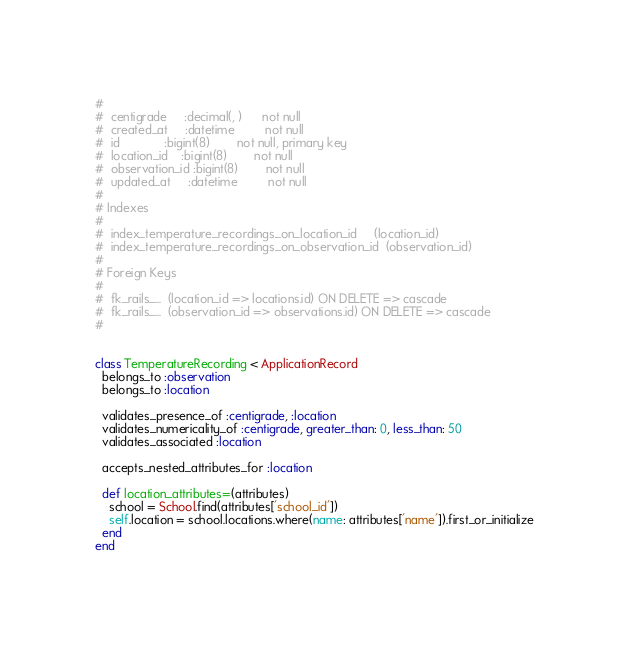<code> <loc_0><loc_0><loc_500><loc_500><_Ruby_>#
#  centigrade     :decimal(, )      not null
#  created_at     :datetime         not null
#  id             :bigint(8)        not null, primary key
#  location_id    :bigint(8)        not null
#  observation_id :bigint(8)        not null
#  updated_at     :datetime         not null
#
# Indexes
#
#  index_temperature_recordings_on_location_id     (location_id)
#  index_temperature_recordings_on_observation_id  (observation_id)
#
# Foreign Keys
#
#  fk_rails_...  (location_id => locations.id) ON DELETE => cascade
#  fk_rails_...  (observation_id => observations.id) ON DELETE => cascade
#


class TemperatureRecording < ApplicationRecord
  belongs_to :observation
  belongs_to :location

  validates_presence_of :centigrade, :location
  validates_numericality_of :centigrade, greater_than: 0, less_than: 50
  validates_associated :location

  accepts_nested_attributes_for :location

  def location_attributes=(attributes)
    school = School.find(attributes['school_id'])
    self.location = school.locations.where(name: attributes['name']).first_or_initialize
  end
end
</code> 